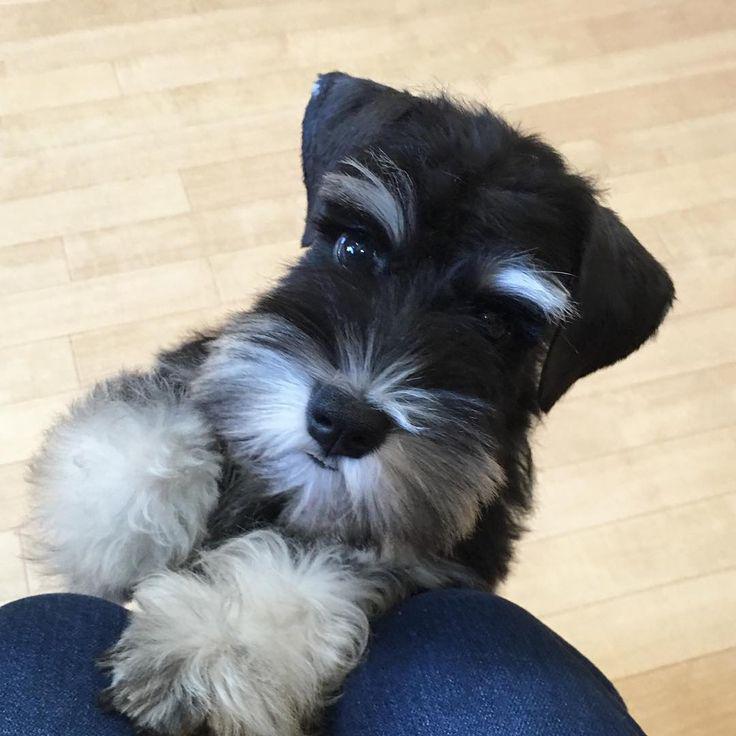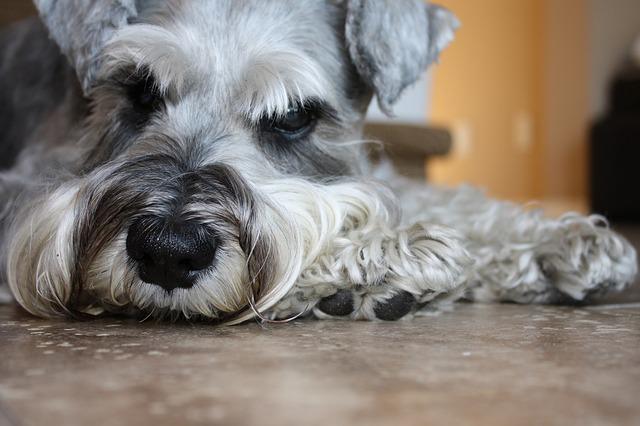The first image is the image on the left, the second image is the image on the right. Considering the images on both sides, is "An image shows a black-faced schnauzer with something blue by its front paws." valid? Answer yes or no. Yes. 